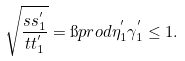Convert formula to latex. <formula><loc_0><loc_0><loc_500><loc_500>\sqrt { \frac { s s _ { 1 } ^ { ^ { \prime } } } { t t _ { 1 } ^ { ^ { \prime } } } } = \i p r o d { \eta _ { 1 } ^ { ^ { \prime } } } { \gamma _ { 1 } ^ { ^ { \prime } } } \leq 1 .</formula> 